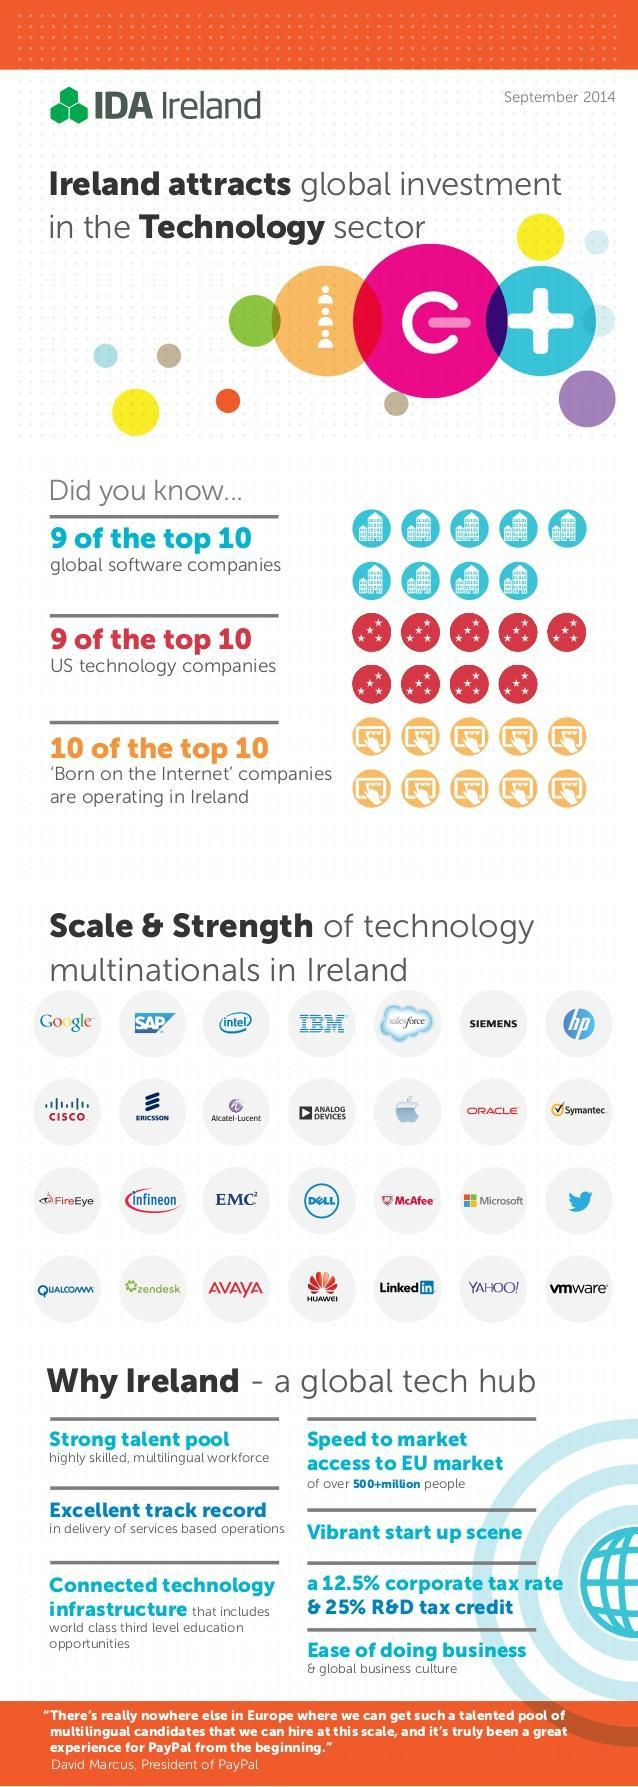Out of 10, how many US technology companies are not operating in Ireland?
Answer the question with a short phrase. 1 Out of 10, how many global software companies are not operating in Ireland? 1 